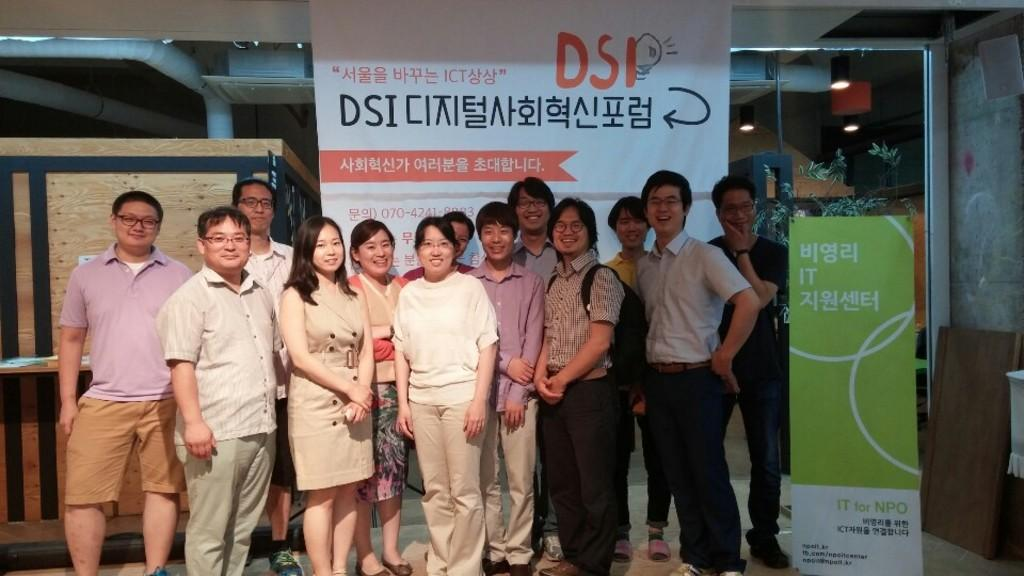What is happening in the middle of the image? There is a group of people in the middle of the image. What are the people doing? The people are standing and laughing. What can be seen at the back side of the image? There is a banner at the back side of the image. What is visible on the right side of the image? There are ceiling lights on the right side of the image. What word is being used to describe the ongoing war in the image? There is no mention of a war or any related words in the image. 